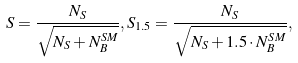Convert formula to latex. <formula><loc_0><loc_0><loc_500><loc_500>S = \frac { N _ { S } } { \sqrt { N _ { S } + N ^ { S M } _ { B } } } , S _ { 1 . 5 } = \frac { N _ { S } } { \sqrt { N _ { S } + 1 . 5 \cdot N ^ { S M } _ { B } } } ,</formula> 